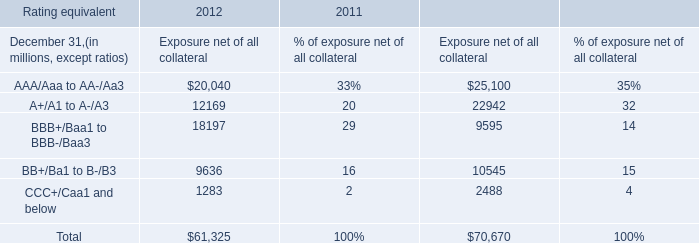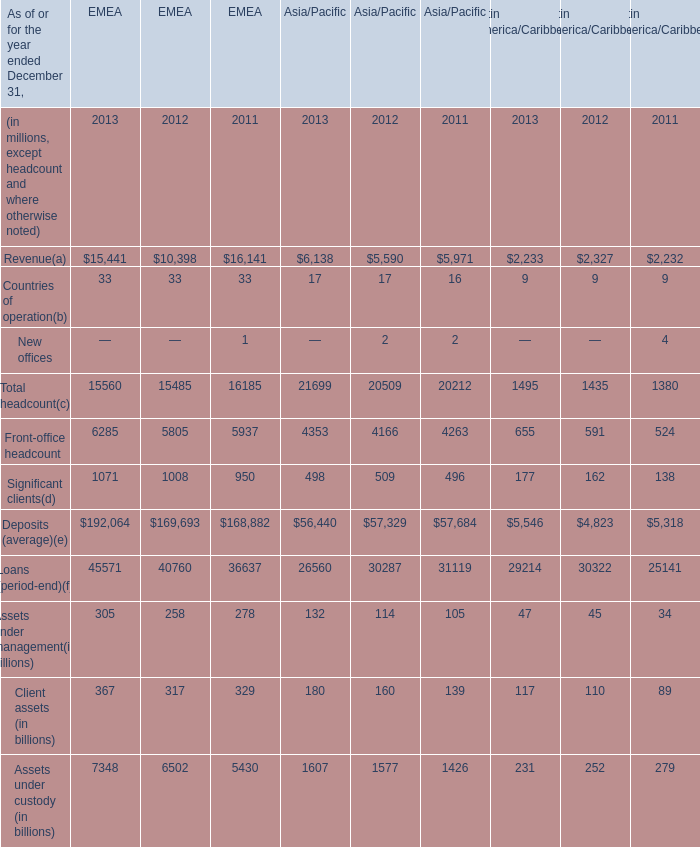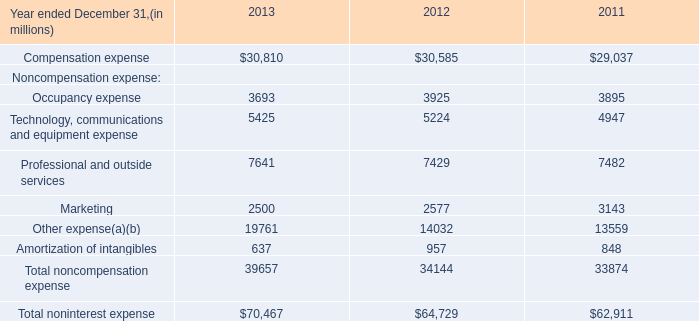What is the sum of the Front-office headcount in the year where Significant clients greater than 1700? (in million) 
Computations: ((6285 + 4353) + 655)
Answer: 11293.0. 